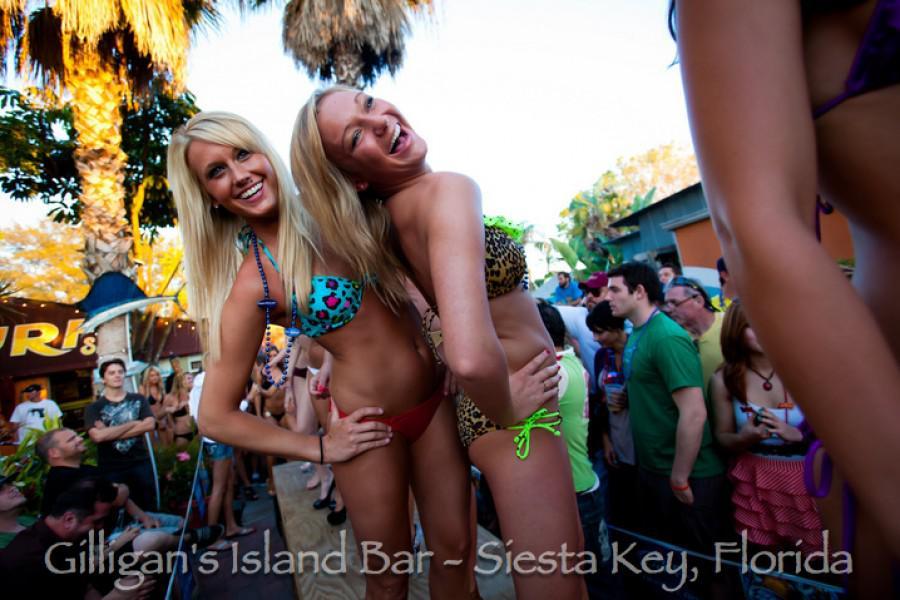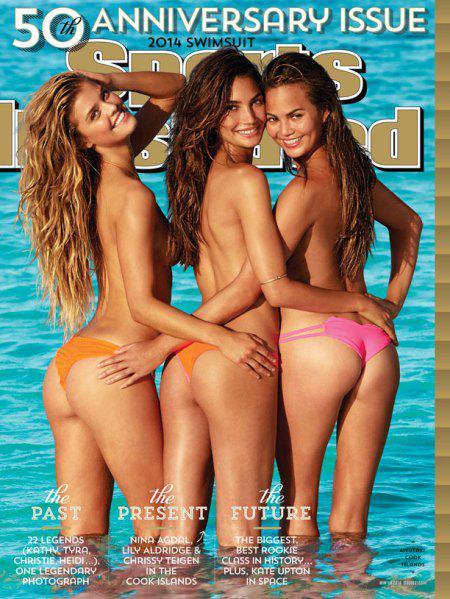The first image is the image on the left, the second image is the image on the right. Given the left and right images, does the statement "Two women are posing in bikinis in the image on the left." hold true? Answer yes or no. Yes. The first image is the image on the left, the second image is the image on the right. For the images shown, is this caption "An image shows exactly three bikini models posed side-by-side, and at least one wears an orange bikini bottom." true? Answer yes or no. Yes. 